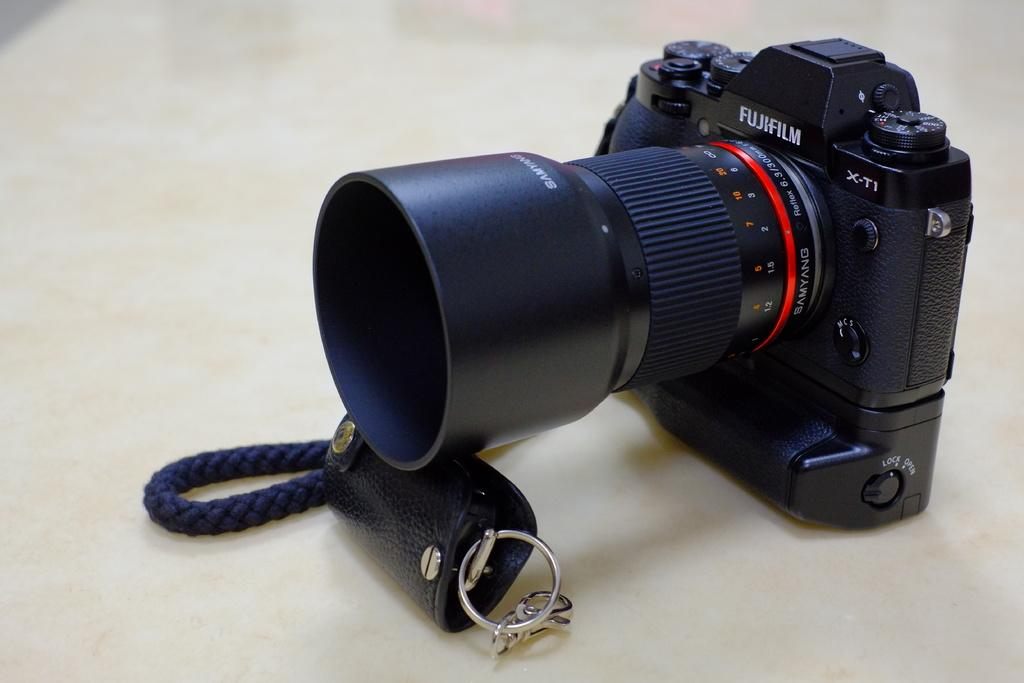<image>
Create a compact narrative representing the image presented. Black Fujifilm camera rested on top of a keychain. 